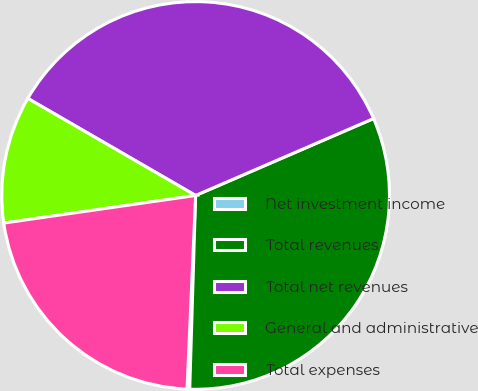Convert chart. <chart><loc_0><loc_0><loc_500><loc_500><pie_chart><fcel>Net investment income<fcel>Total revenues<fcel>Total net revenues<fcel>General and administrative<fcel>Total expenses<nl><fcel>0.22%<fcel>31.98%<fcel>35.16%<fcel>10.62%<fcel>22.02%<nl></chart> 